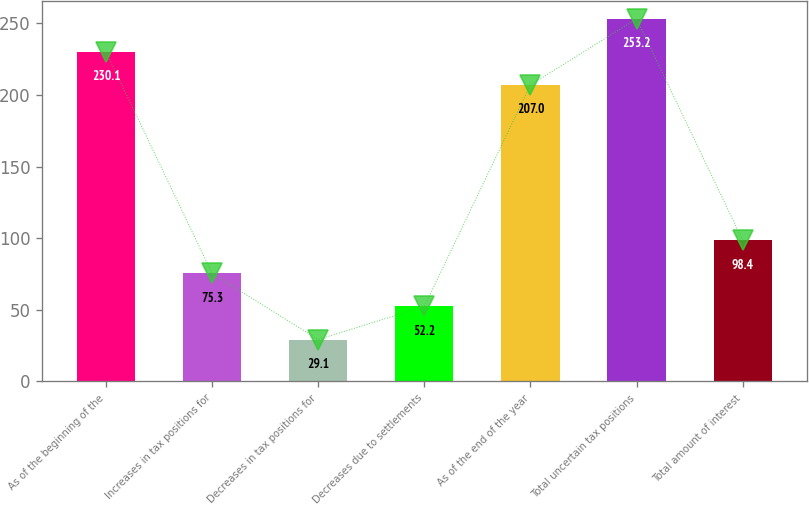Convert chart to OTSL. <chart><loc_0><loc_0><loc_500><loc_500><bar_chart><fcel>As of the beginning of the<fcel>Increases in tax positions for<fcel>Decreases in tax positions for<fcel>Decreases due to settlements<fcel>As of the end of the year<fcel>Total uncertain tax positions<fcel>Total amount of interest<nl><fcel>230.1<fcel>75.3<fcel>29.1<fcel>52.2<fcel>207<fcel>253.2<fcel>98.4<nl></chart> 